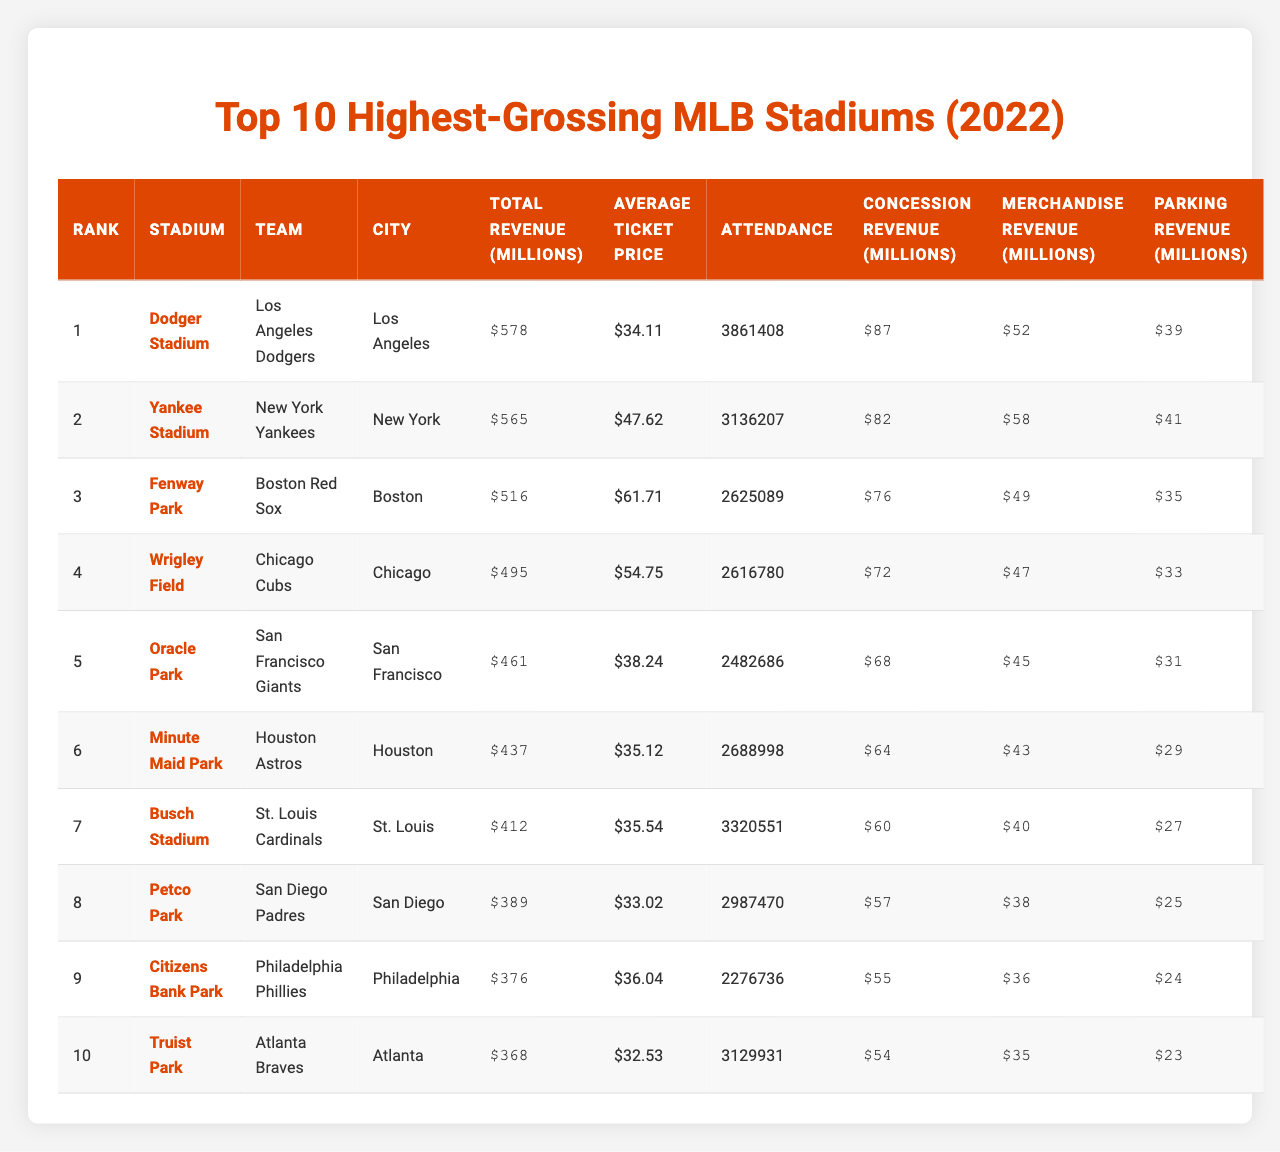What is the total revenue generated by Dodger Stadium? The table shows that Dodger Stadium, ranked number one, has a total revenue of $578 million.
Answer: $578 million Which stadium had the highest average ticket price? Fenway Park has the highest average ticket price listed at $61.71.
Answer: Fenway Park True or False: Citizens Bank Park has more total revenue than Oracle Park. Citizens Bank Park has a total revenue of $376 million while Oracle Park has $461 million, indicating that the statement is false.
Answer: False What is the difference in total revenue between Yankee Stadium and Fenway Park? Yankee Stadium earned $565 million and Fenway Park earned $516 million. The difference is $565 million - $516 million = $49 million.
Answer: $49 million How many stadiums generated more than $500 million in total revenue? The table indicates that there are three stadiums with total revenue over $500 million: Dodger Stadium, Yankee Stadium, and Fenway Park.
Answer: 3 Which stadium had the lowest concession revenue and what was it? Petco Park had the lowest concession revenue listed at $57 million.
Answer: $57 million What is the average attendance of the top 10 stadiums? To calculate the average, sum the attendance figures: 3861408 + 3136207 + 2625089 + 2616780 + 2482686 + 2688998 + 3320551 + 2987470 + 2276736 + 3129931 = 27483556. Then divide by 10 to get the average: 27483556 / 10 = 2748355.6.
Answer: 2,748,356 What percentage of total revenue comes from merchandise revenue for the highest-grossing stadium? For Dodger Stadium, merchandise revenue is $39 million. Total revenue is $578 million. The percentage is ($39 million / $578 million) * 100 = 6.75%.
Answer: 6.75% Which team has the lowest parking revenue and what is that amount? Truist Park has the lowest parking revenue at $23 million.
Answer: $23 million Is the average ticket price at Minute Maid Park higher than that of Petco Park? Minute Maid Park’s average ticket price is $35.12 while Petco Park is $33.02, making Minute Maid Park's price higher.
Answer: Yes 